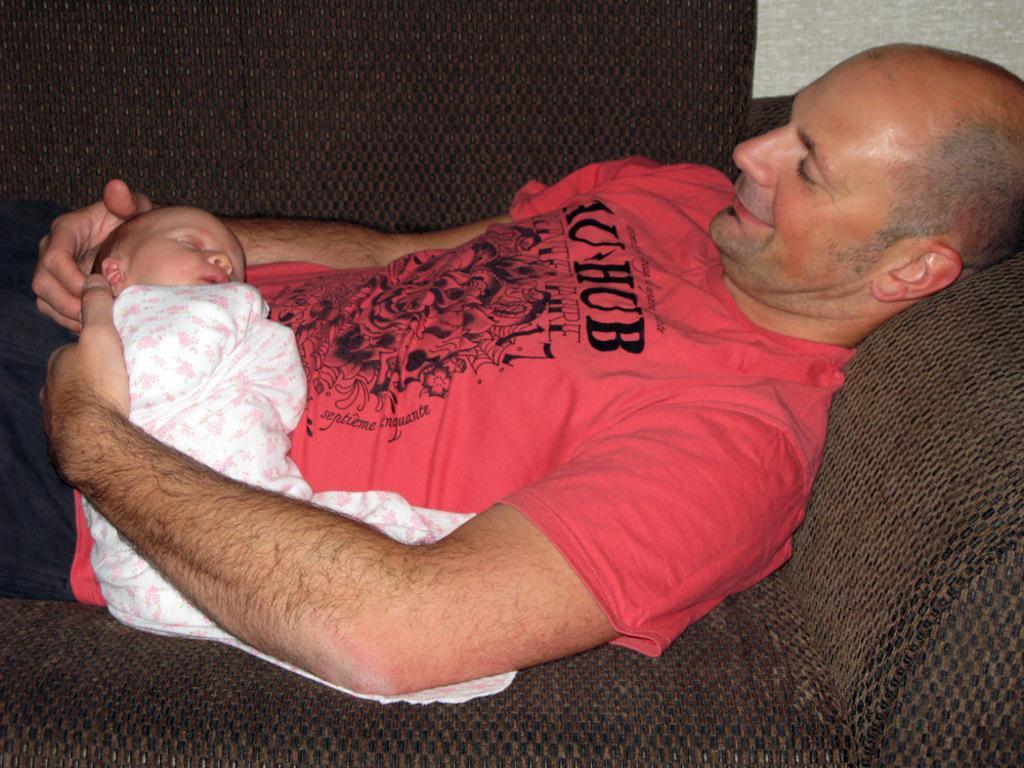Please provide a concise description of this image. In this image I can see a man wearing red color t-shirt, holding a baby in the hands and laying on a couch. He is smiling. The couch is in brown color. 